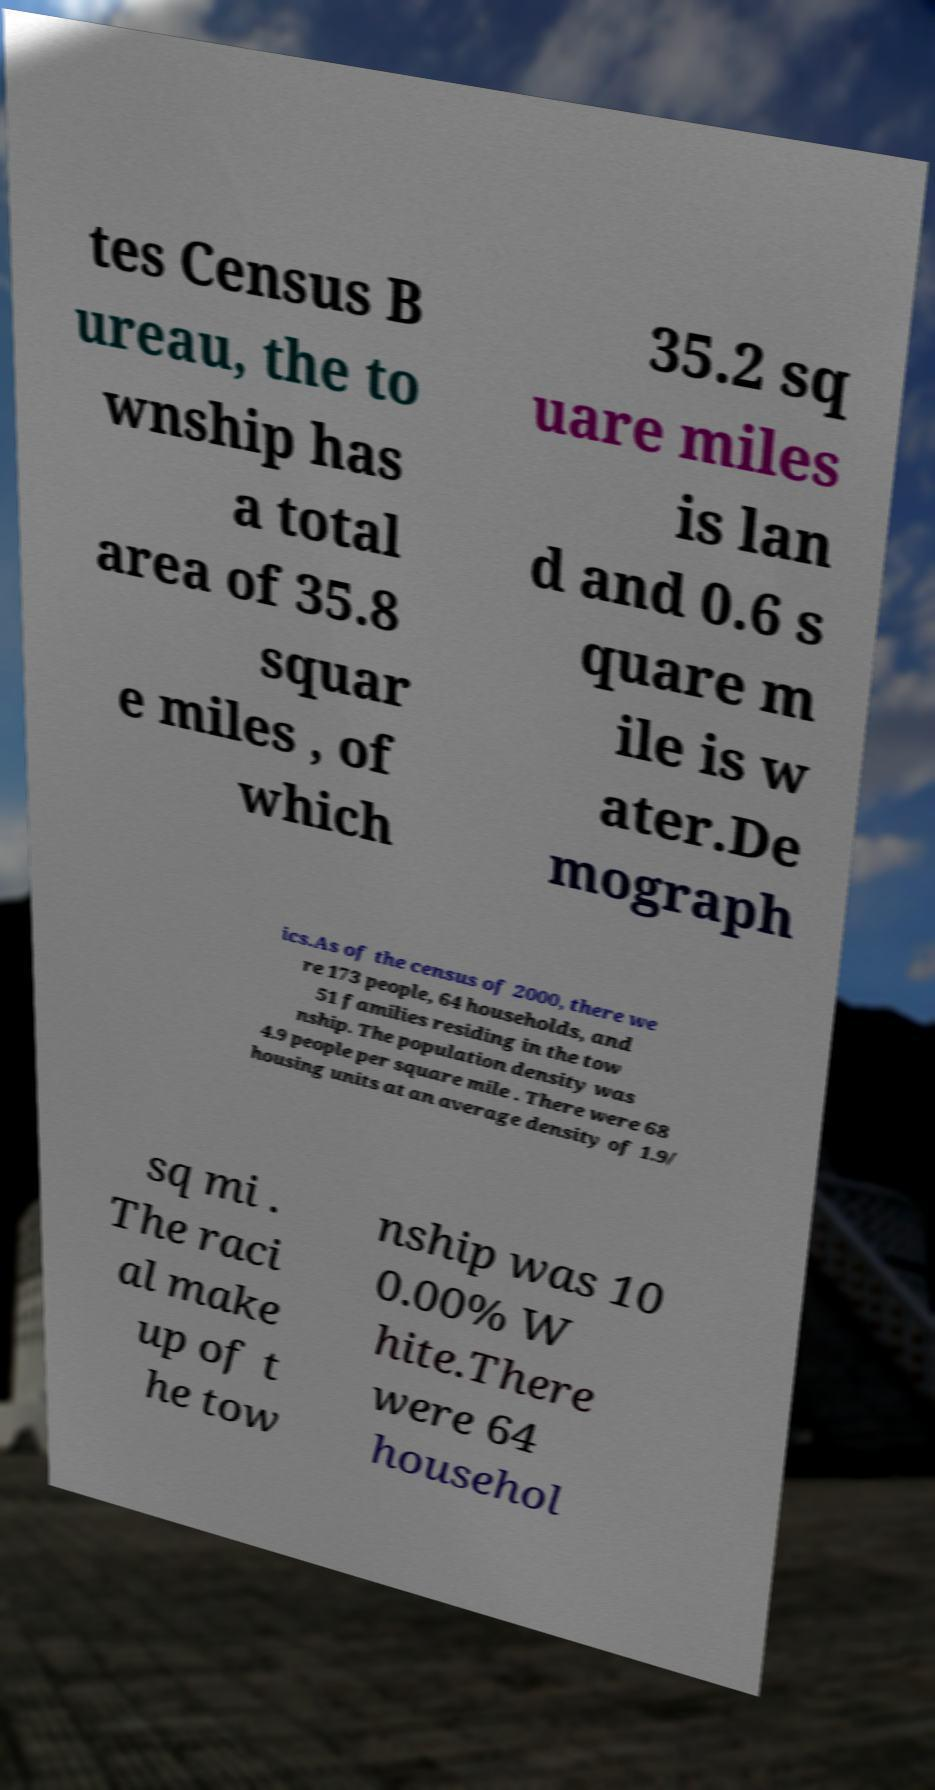Could you extract and type out the text from this image? tes Census B ureau, the to wnship has a total area of 35.8 squar e miles , of which 35.2 sq uare miles is lan d and 0.6 s quare m ile is w ater.De mograph ics.As of the census of 2000, there we re 173 people, 64 households, and 51 families residing in the tow nship. The population density was 4.9 people per square mile . There were 68 housing units at an average density of 1.9/ sq mi . The raci al make up of t he tow nship was 10 0.00% W hite.There were 64 househol 